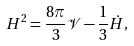<formula> <loc_0><loc_0><loc_500><loc_500>H ^ { 2 } = \frac { 8 \pi } { 3 } \mathcal { V } - \frac { 1 } { 3 } \dot { H } ,</formula> 